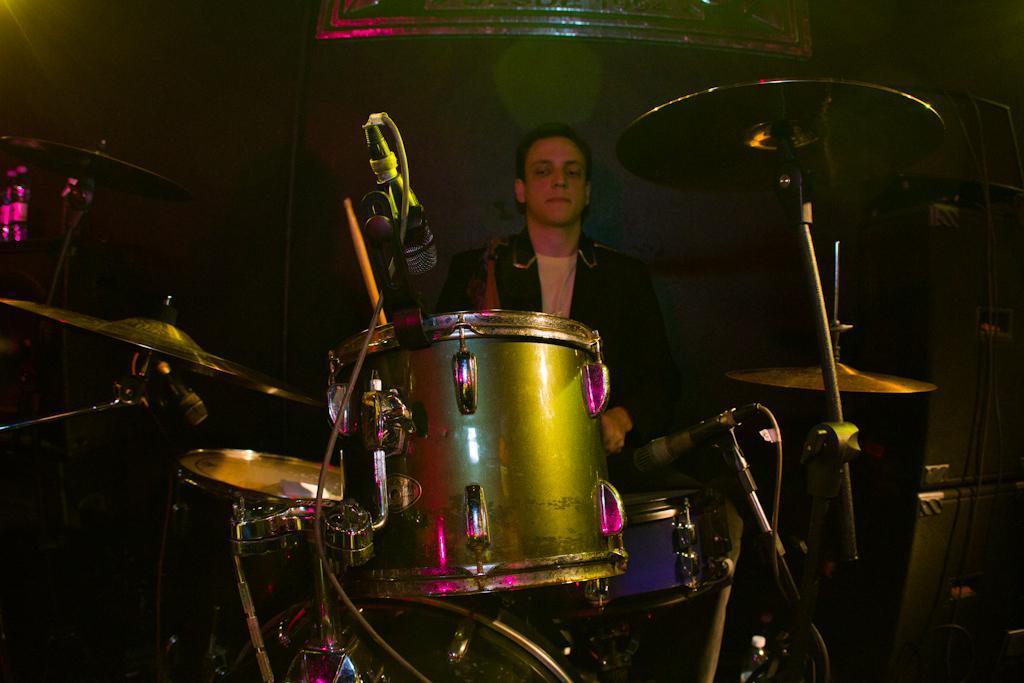Please provide a concise description of this image. In the image we can see a person sitting and wearing clothes. Here we can see musical instruments, microphone and cable wire. 